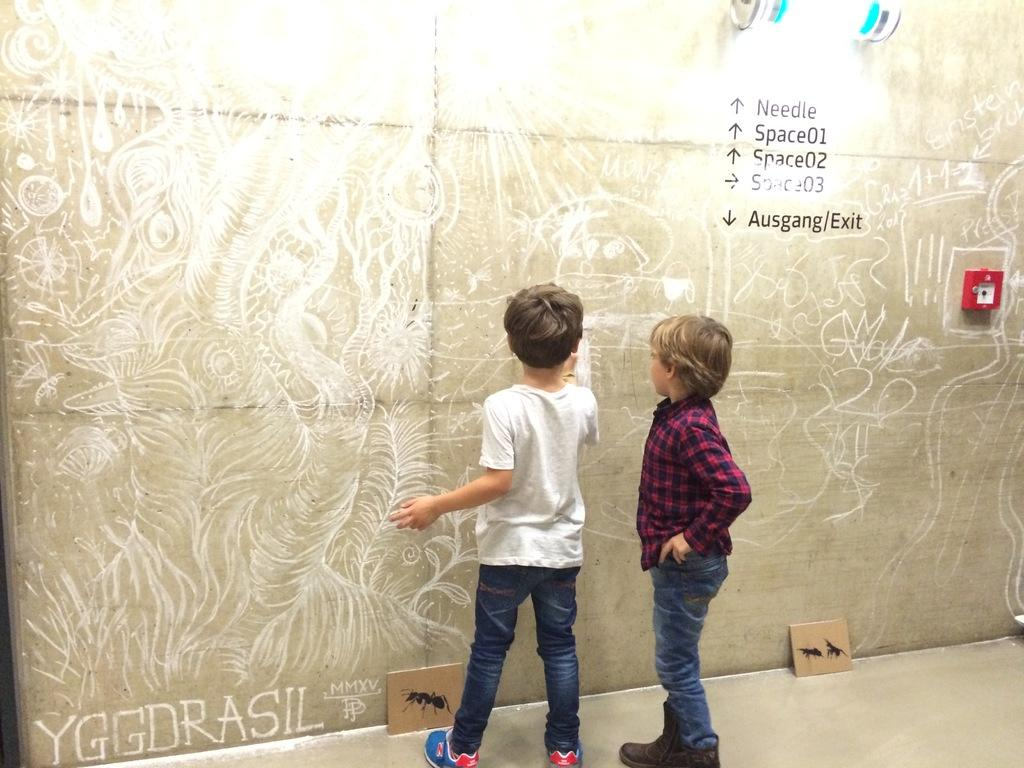How many children are present in the image? There are two children in the image. What is one of the children doing in the image? One of the children is writing on the wall. What can be seen on the wall besides the child writing? There are paintings and other objects on the wall. What type of drum is the judge playing in the image? There is no drum or judge present in the image. 